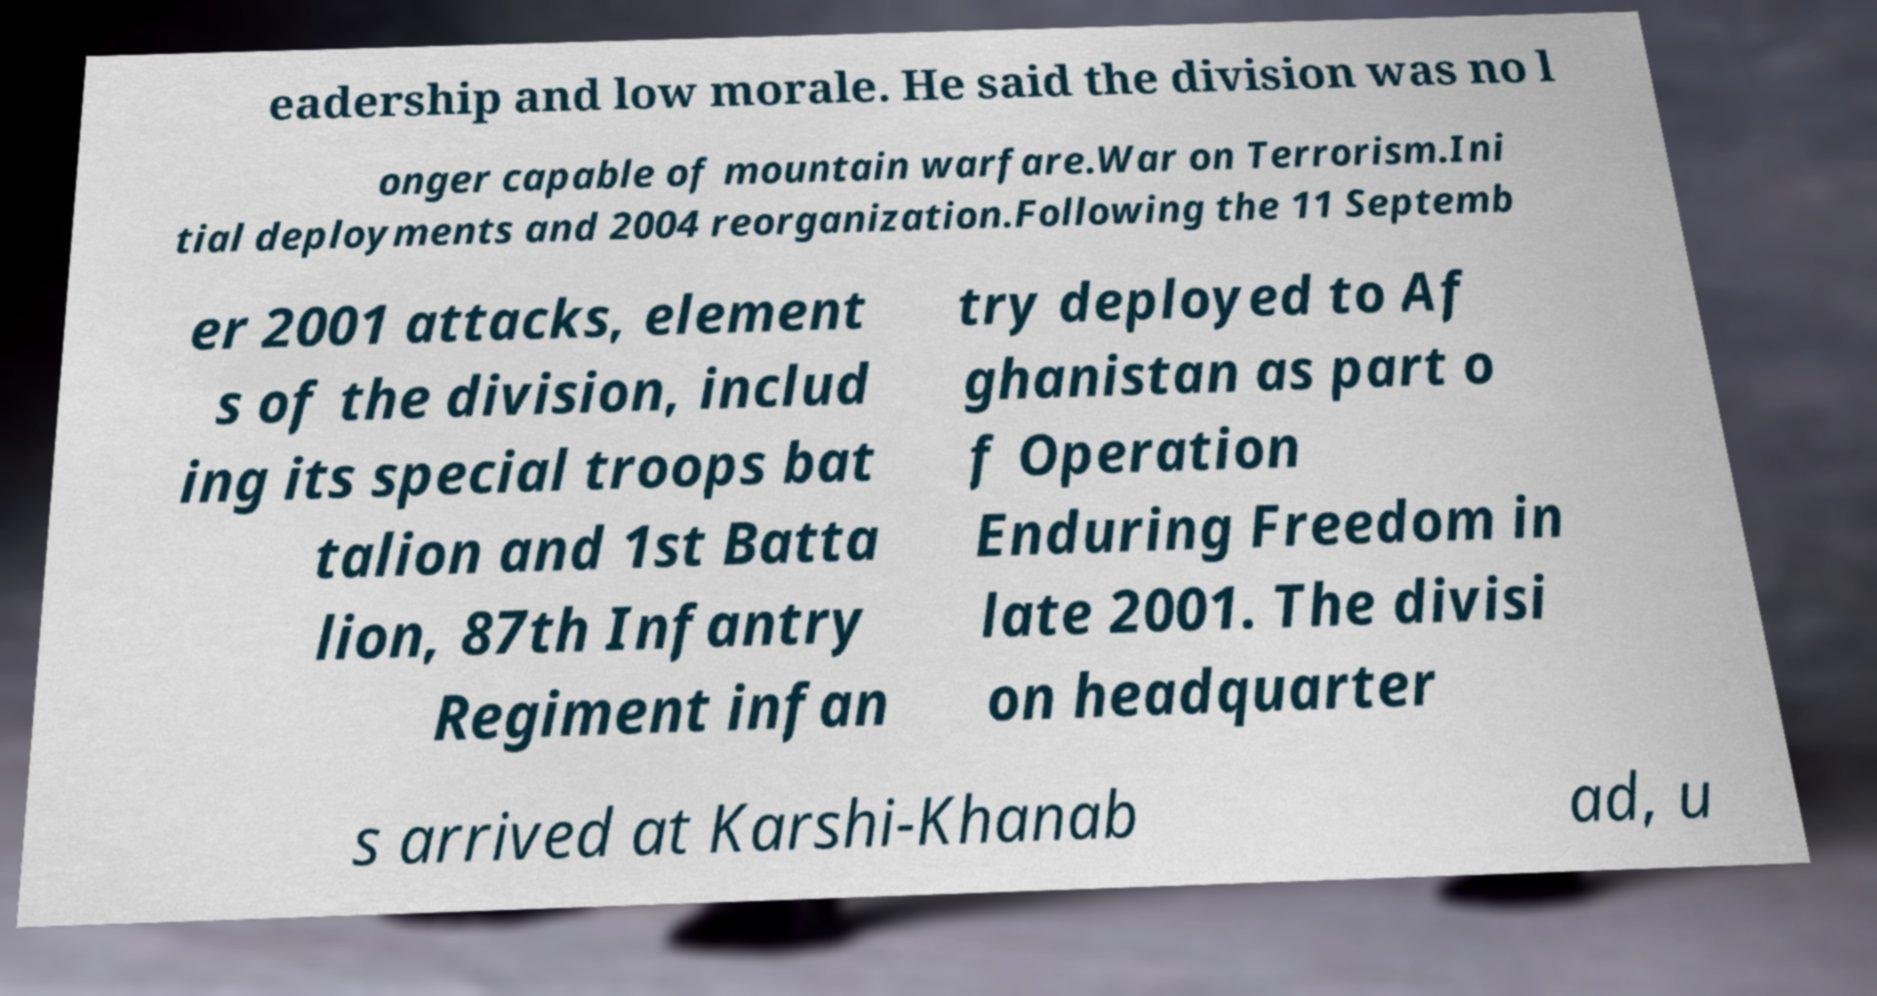Please identify and transcribe the text found in this image. eadership and low morale. He said the division was no l onger capable of mountain warfare.War on Terrorism.Ini tial deployments and 2004 reorganization.Following the 11 Septemb er 2001 attacks, element s of the division, includ ing its special troops bat talion and 1st Batta lion, 87th Infantry Regiment infan try deployed to Af ghanistan as part o f Operation Enduring Freedom in late 2001. The divisi on headquarter s arrived at Karshi-Khanab ad, u 